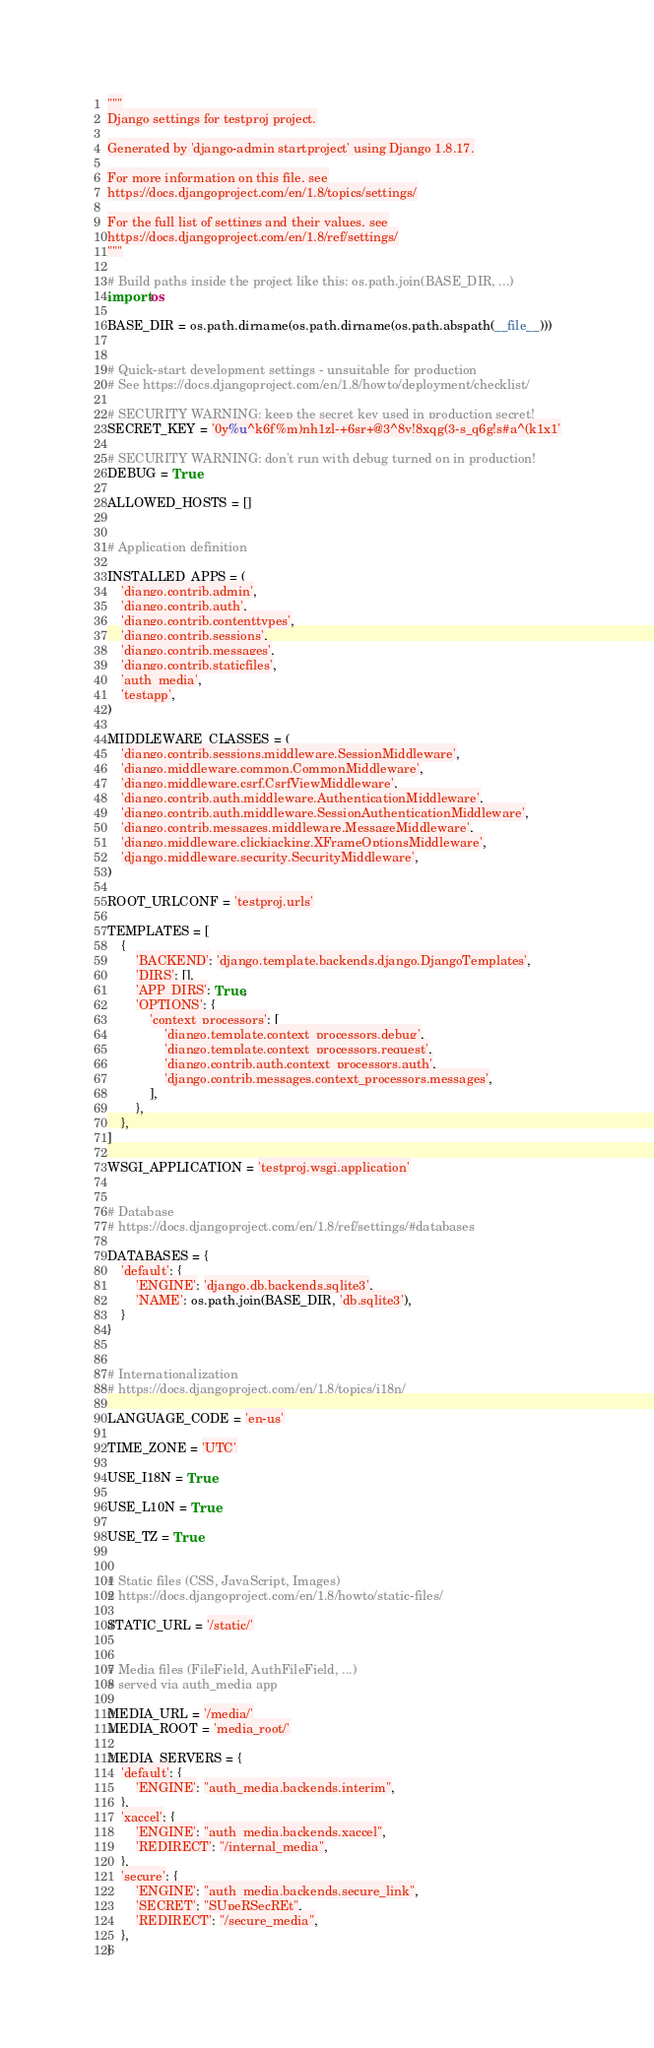<code> <loc_0><loc_0><loc_500><loc_500><_Python_>"""
Django settings for testproj project.

Generated by 'django-admin startproject' using Django 1.8.17.

For more information on this file, see
https://docs.djangoproject.com/en/1.8/topics/settings/

For the full list of settings and their values, see
https://docs.djangoproject.com/en/1.8/ref/settings/
"""

# Build paths inside the project like this: os.path.join(BASE_DIR, ...)
import os

BASE_DIR = os.path.dirname(os.path.dirname(os.path.abspath(__file__)))


# Quick-start development settings - unsuitable for production
# See https://docs.djangoproject.com/en/1.8/howto/deployment/checklist/

# SECURITY WARNING: keep the secret key used in production secret!
SECRET_KEY = '0y%u^k6f%m)nh1zl-+6sr+@3^8v!8xqg(3-s_q6g!s#a^(k1x1'

# SECURITY WARNING: don't run with debug turned on in production!
DEBUG = True

ALLOWED_HOSTS = []


# Application definition

INSTALLED_APPS = (
    'django.contrib.admin',
    'django.contrib.auth',
    'django.contrib.contenttypes',
    'django.contrib.sessions',
    'django.contrib.messages',
    'django.contrib.staticfiles',
    'auth_media',
    'testapp',
)

MIDDLEWARE_CLASSES = (
    'django.contrib.sessions.middleware.SessionMiddleware',
    'django.middleware.common.CommonMiddleware',
    'django.middleware.csrf.CsrfViewMiddleware',
    'django.contrib.auth.middleware.AuthenticationMiddleware',
    'django.contrib.auth.middleware.SessionAuthenticationMiddleware',
    'django.contrib.messages.middleware.MessageMiddleware',
    'django.middleware.clickjacking.XFrameOptionsMiddleware',
    'django.middleware.security.SecurityMiddleware',
)

ROOT_URLCONF = 'testproj.urls'

TEMPLATES = [
    {
        'BACKEND': 'django.template.backends.django.DjangoTemplates',
        'DIRS': [],
        'APP_DIRS': True,
        'OPTIONS': {
            'context_processors': [
                'django.template.context_processors.debug',
                'django.template.context_processors.request',
                'django.contrib.auth.context_processors.auth',
                'django.contrib.messages.context_processors.messages',
            ],
        },
    },
]

WSGI_APPLICATION = 'testproj.wsgi.application'


# Database
# https://docs.djangoproject.com/en/1.8/ref/settings/#databases

DATABASES = {
    'default': {
        'ENGINE': 'django.db.backends.sqlite3',
        'NAME': os.path.join(BASE_DIR, 'db.sqlite3'),
    }
}


# Internationalization
# https://docs.djangoproject.com/en/1.8/topics/i18n/

LANGUAGE_CODE = 'en-us'

TIME_ZONE = 'UTC'

USE_I18N = True

USE_L10N = True

USE_TZ = True


# Static files (CSS, JavaScript, Images)
# https://docs.djangoproject.com/en/1.8/howto/static-files/

STATIC_URL = '/static/'


# Media files (FileField, AuthFileField, ...)
# served via auth_media app

MEDIA_URL = '/media/'
MEDIA_ROOT = 'media_root/'

MEDIA_SERVERS = {
    'default': {
        'ENGINE': "auth_media.backends.interim",
    },
    'xaccel': {
        'ENGINE': "auth_media.backends.xaccel",
        'REDIRECT': "/internal_media",
    },
    'secure': {
        'ENGINE': "auth_media.backends.secure_link",
        'SECRET': "SUpeRSecREt",
        'REDIRECT': "/secure_media",
    },
}
</code> 